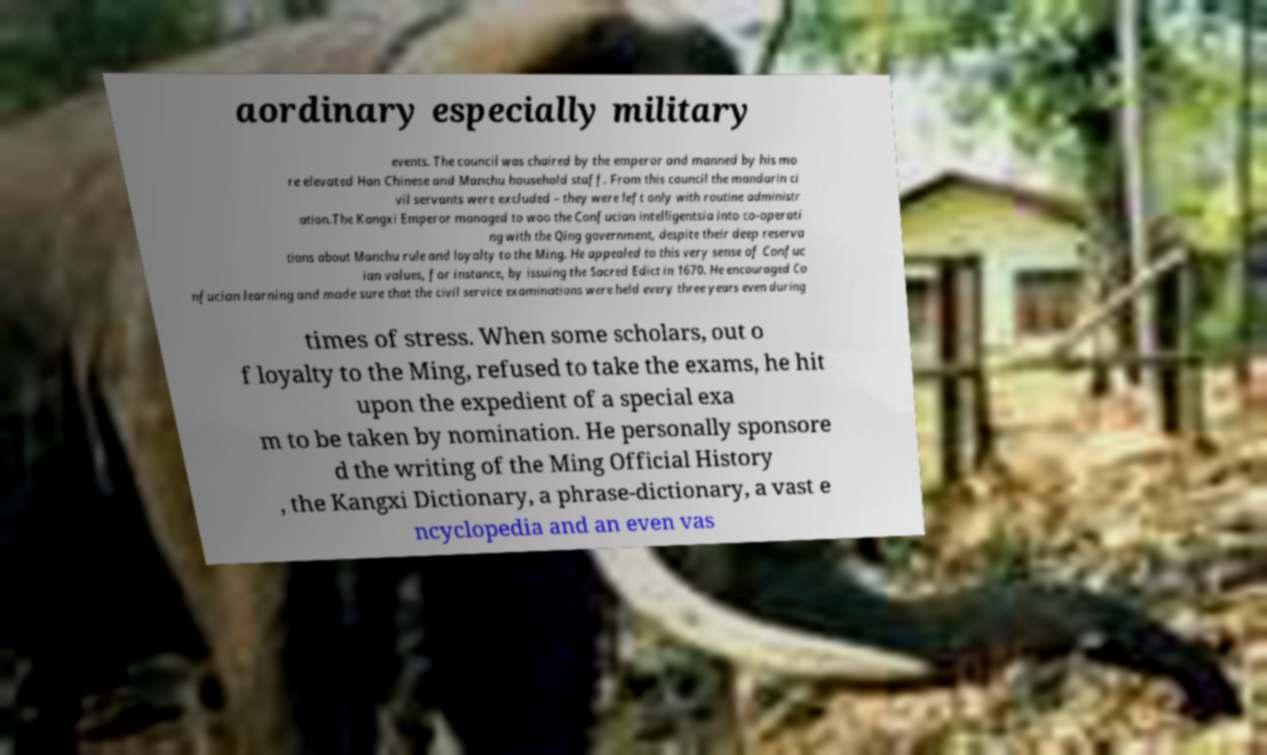Can you read and provide the text displayed in the image?This photo seems to have some interesting text. Can you extract and type it out for me? aordinary especially military events. The council was chaired by the emperor and manned by his mo re elevated Han Chinese and Manchu household staff. From this council the mandarin ci vil servants were excluded – they were left only with routine administr ation.The Kangxi Emperor managed to woo the Confucian intelligentsia into co-operati ng with the Qing government, despite their deep reserva tions about Manchu rule and loyalty to the Ming. He appealed to this very sense of Confuc ian values, for instance, by issuing the Sacred Edict in 1670. He encouraged Co nfucian learning and made sure that the civil service examinations were held every three years even during times of stress. When some scholars, out o f loyalty to the Ming, refused to take the exams, he hit upon the expedient of a special exa m to be taken by nomination. He personally sponsore d the writing of the Ming Official History , the Kangxi Dictionary, a phrase-dictionary, a vast e ncyclopedia and an even vas 